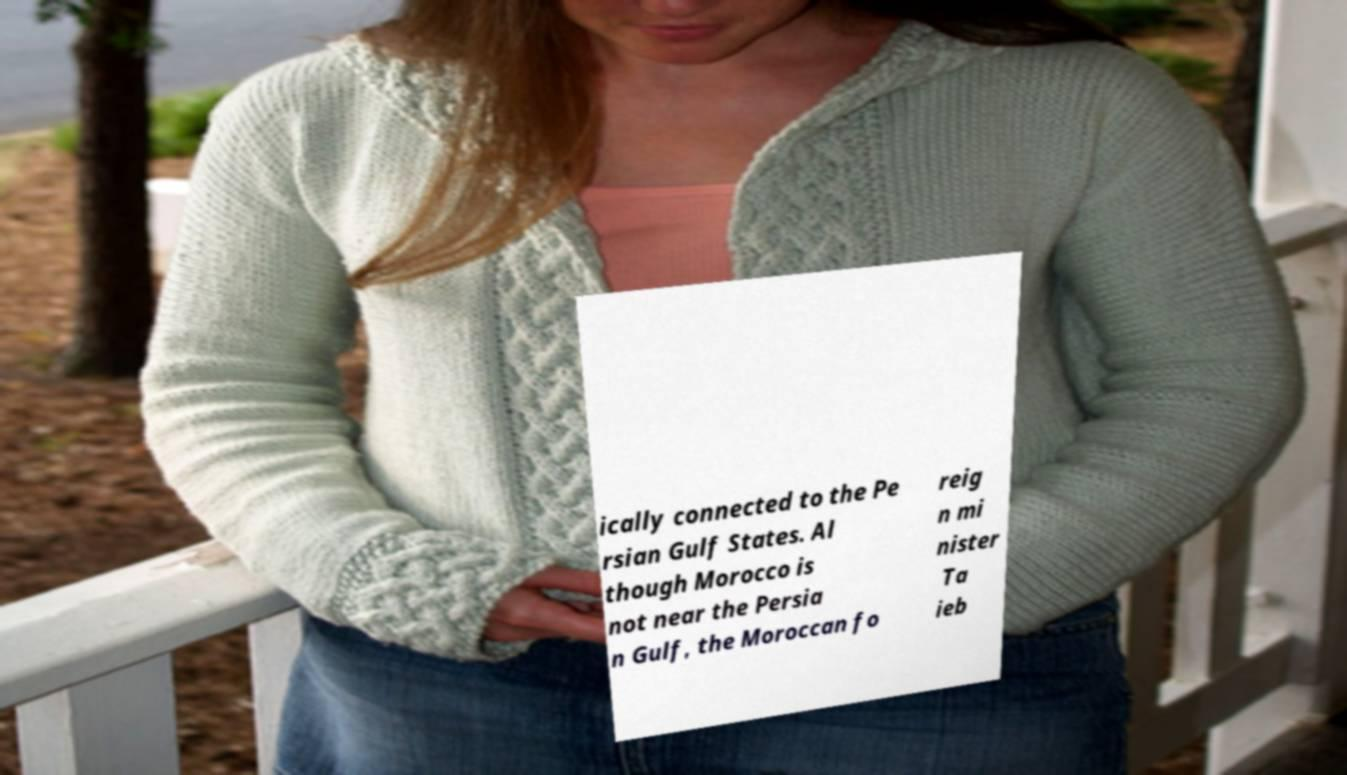Please identify and transcribe the text found in this image. ically connected to the Pe rsian Gulf States. Al though Morocco is not near the Persia n Gulf, the Moroccan fo reig n mi nister Ta ieb 